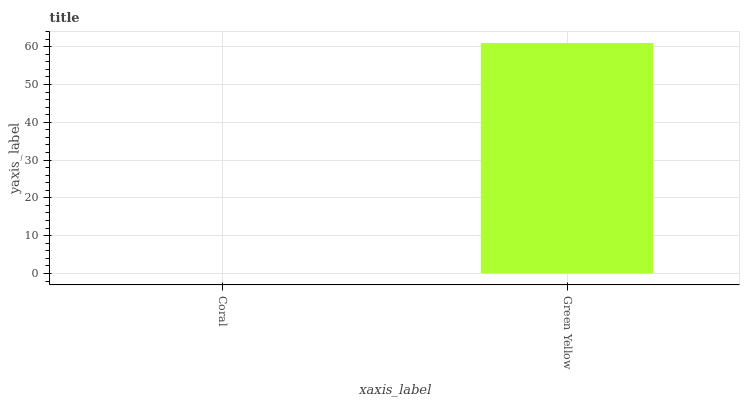Is Coral the minimum?
Answer yes or no. Yes. Is Green Yellow the maximum?
Answer yes or no. Yes. Is Green Yellow the minimum?
Answer yes or no. No. Is Green Yellow greater than Coral?
Answer yes or no. Yes. Is Coral less than Green Yellow?
Answer yes or no. Yes. Is Coral greater than Green Yellow?
Answer yes or no. No. Is Green Yellow less than Coral?
Answer yes or no. No. Is Green Yellow the high median?
Answer yes or no. Yes. Is Coral the low median?
Answer yes or no. Yes. Is Coral the high median?
Answer yes or no. No. Is Green Yellow the low median?
Answer yes or no. No. 